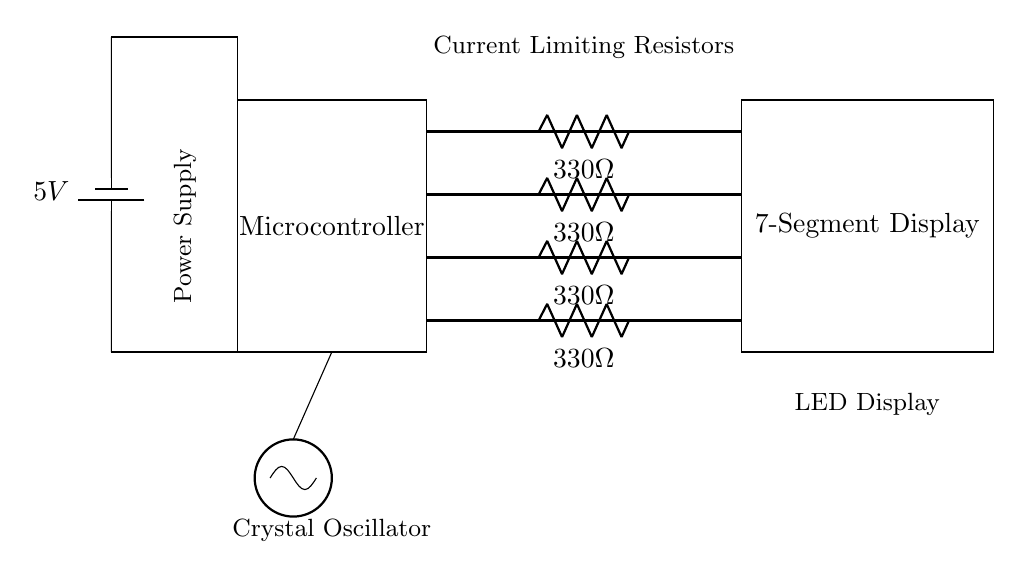What type of display is used in the circuit? The circuit uses a 7-segment display, which is indicated by the label on the rectangle representing the display in the diagram.
Answer: 7-segment display What is the value of the current limiting resistor? The current limiting resistors are labeled as 330 ohms, which can be seen next to the resistors in the circuit diagram.
Answer: 330 ohm What is the voltage supplied to the circuit? The circuit is powered by a 5V battery, which is clearly marked in the circuit diagram along the power supply components.
Answer: 5V How many resistors are present in the circuit? There are four resistors shown in the circuit diagram, as indicated by the four lines labeled with the resistor value next to vertical spaces in the diagram.
Answer: Four What is the purpose of the crystal oscillator in the circuit? The crystal oscillator is used to generate a stable clock signal for timing purposes, which is essential for a digital clock's operation. This role is indicated by the labeled component in the diagram.
Answer: Clock signal What connects the microcontroller to the display? The microcontroller is connected to the 7-segment display through four thick lines, which represent the data connections needed to control the display segments.
Answer: Four lines What is the function of the current limiting resistors? The purpose of the current limiting resistors is to prevent excessive current from flowing through the LEDs in the display, ensuring they operate safely without damage. This function is highlighted in their description in the diagram.
Answer: Limit current 